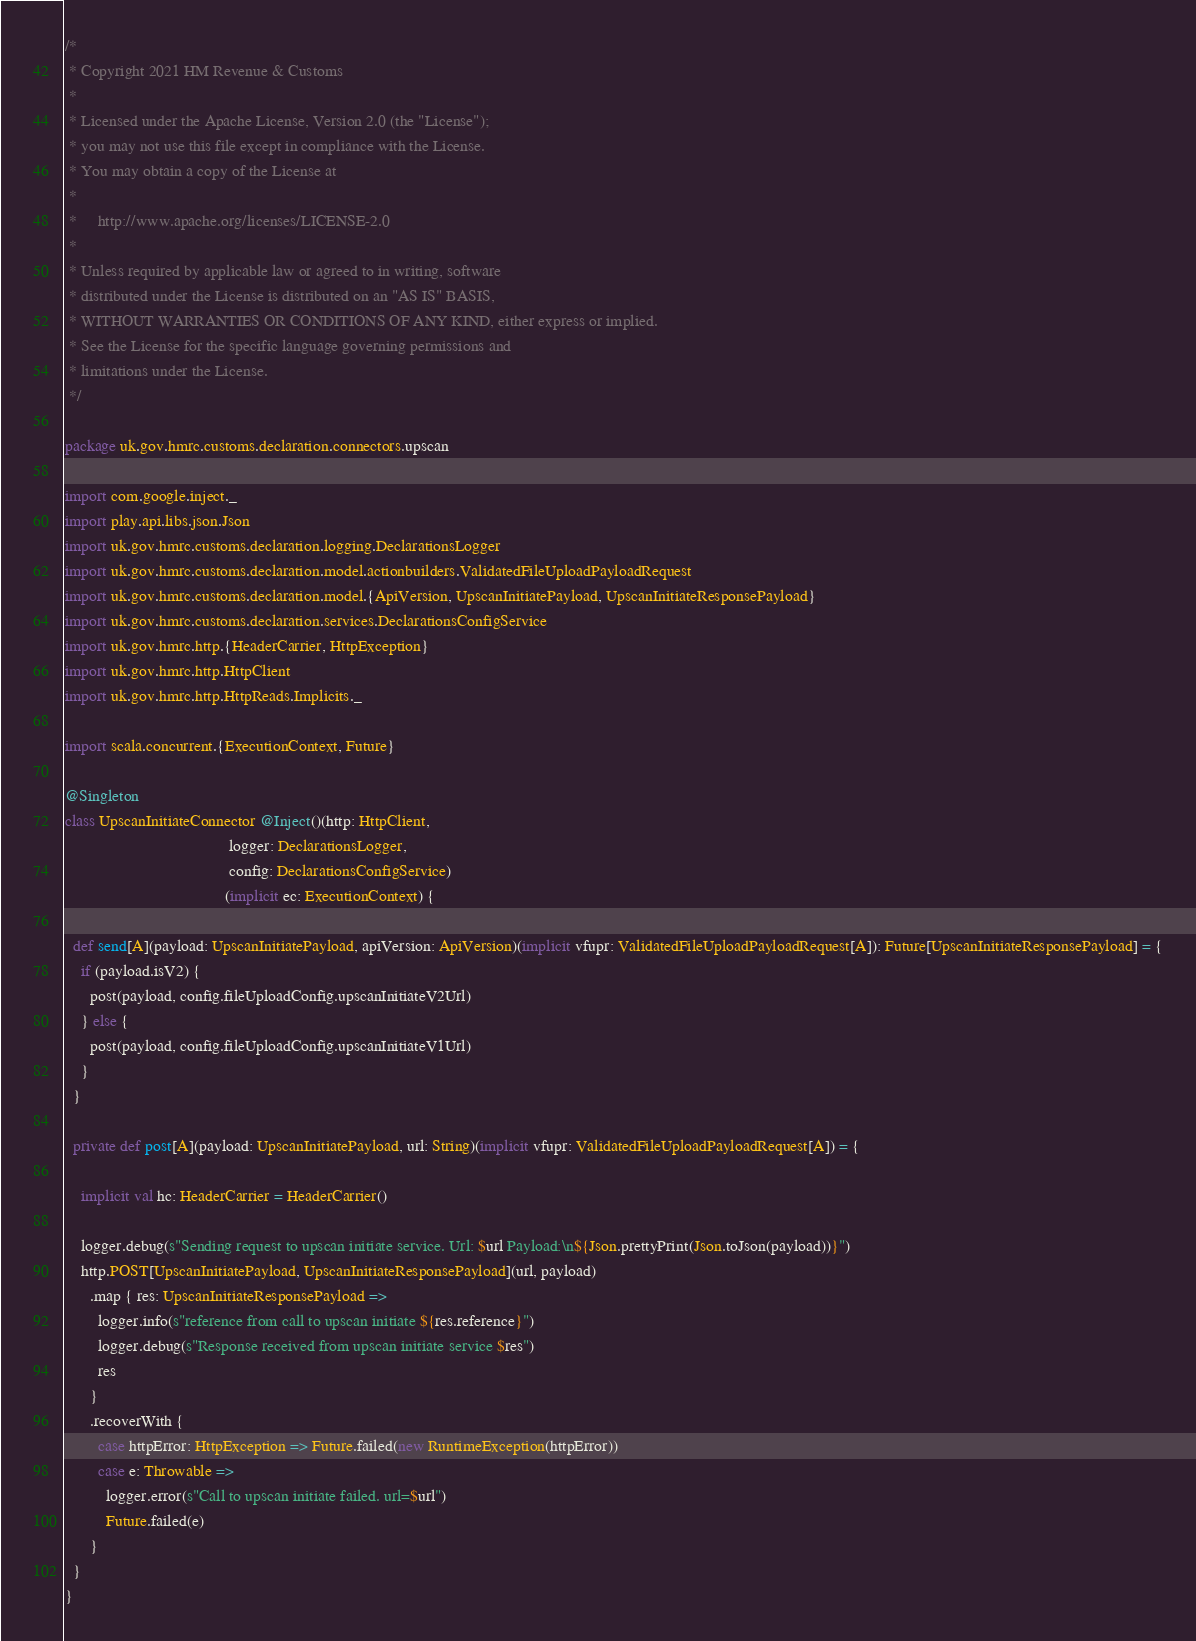<code> <loc_0><loc_0><loc_500><loc_500><_Scala_>/*
 * Copyright 2021 HM Revenue & Customs
 *
 * Licensed under the Apache License, Version 2.0 (the "License");
 * you may not use this file except in compliance with the License.
 * You may obtain a copy of the License at
 *
 *     http://www.apache.org/licenses/LICENSE-2.0
 *
 * Unless required by applicable law or agreed to in writing, software
 * distributed under the License is distributed on an "AS IS" BASIS,
 * WITHOUT WARRANTIES OR CONDITIONS OF ANY KIND, either express or implied.
 * See the License for the specific language governing permissions and
 * limitations under the License.
 */

package uk.gov.hmrc.customs.declaration.connectors.upscan

import com.google.inject._
import play.api.libs.json.Json
import uk.gov.hmrc.customs.declaration.logging.DeclarationsLogger
import uk.gov.hmrc.customs.declaration.model.actionbuilders.ValidatedFileUploadPayloadRequest
import uk.gov.hmrc.customs.declaration.model.{ApiVersion, UpscanInitiatePayload, UpscanInitiateResponsePayload}
import uk.gov.hmrc.customs.declaration.services.DeclarationsConfigService
import uk.gov.hmrc.http.{HeaderCarrier, HttpException}
import uk.gov.hmrc.http.HttpClient
import uk.gov.hmrc.http.HttpReads.Implicits._

import scala.concurrent.{ExecutionContext, Future}

@Singleton
class UpscanInitiateConnector @Inject()(http: HttpClient,
                                        logger: DeclarationsLogger,
                                        config: DeclarationsConfigService)
                                       (implicit ec: ExecutionContext) {

  def send[A](payload: UpscanInitiatePayload, apiVersion: ApiVersion)(implicit vfupr: ValidatedFileUploadPayloadRequest[A]): Future[UpscanInitiateResponsePayload] = {
    if (payload.isV2) {
      post(payload, config.fileUploadConfig.upscanInitiateV2Url)
    } else {
      post(payload, config.fileUploadConfig.upscanInitiateV1Url)
    }
  }

  private def post[A](payload: UpscanInitiatePayload, url: String)(implicit vfupr: ValidatedFileUploadPayloadRequest[A]) = {

    implicit val hc: HeaderCarrier = HeaderCarrier()

    logger.debug(s"Sending request to upscan initiate service. Url: $url Payload:\n${Json.prettyPrint(Json.toJson(payload))}")
    http.POST[UpscanInitiatePayload, UpscanInitiateResponsePayload](url, payload)
      .map { res: UpscanInitiateResponsePayload =>
        logger.info(s"reference from call to upscan initiate ${res.reference}")
        logger.debug(s"Response received from upscan initiate service $res")
        res
      }
      .recoverWith {
        case httpError: HttpException => Future.failed(new RuntimeException(httpError))
        case e: Throwable =>
          logger.error(s"Call to upscan initiate failed. url=$url")
          Future.failed(e)
      }
  }
}
</code> 